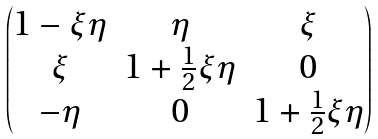Convert formula to latex. <formula><loc_0><loc_0><loc_500><loc_500>\begin{pmatrix} 1 - \xi \eta & \eta & \xi \\ \xi & 1 + \frac { 1 } { 2 } \xi \eta & 0 \\ - \eta & 0 & 1 + \frac { 1 } { 2 } \xi \eta \end{pmatrix}</formula> 